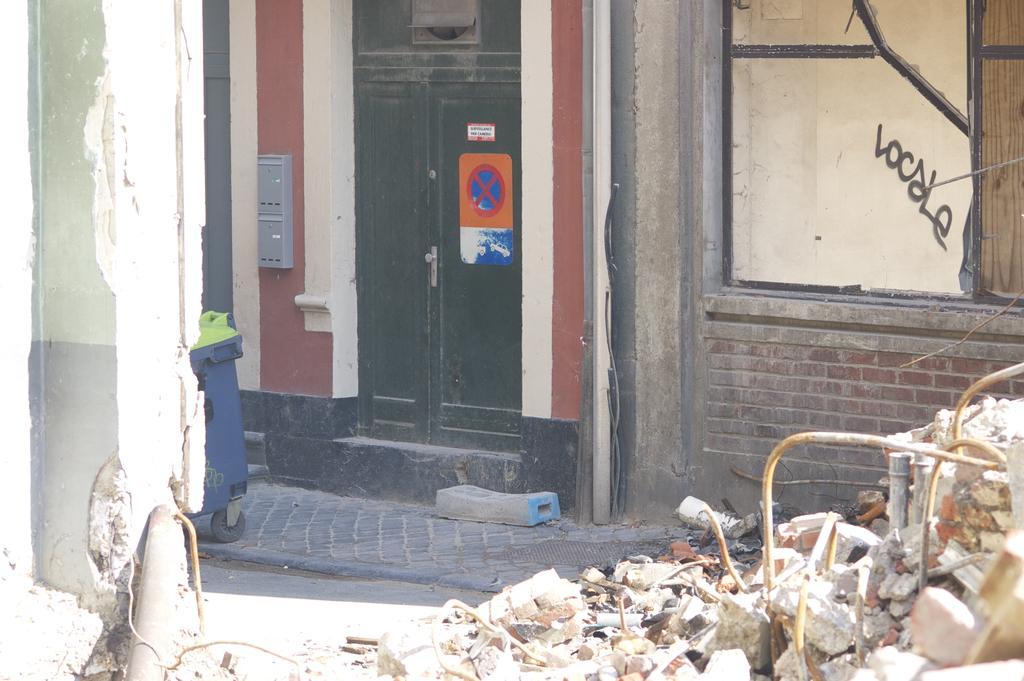How would you summarize this image in a sentence or two? In this image I can see the pipe, the wall and to the right bottom of the image I can see some broken concrete and few pipes. In the background I can see the sidewalk, a bin, a building, the window and the black colored door to which a poster is attached. 